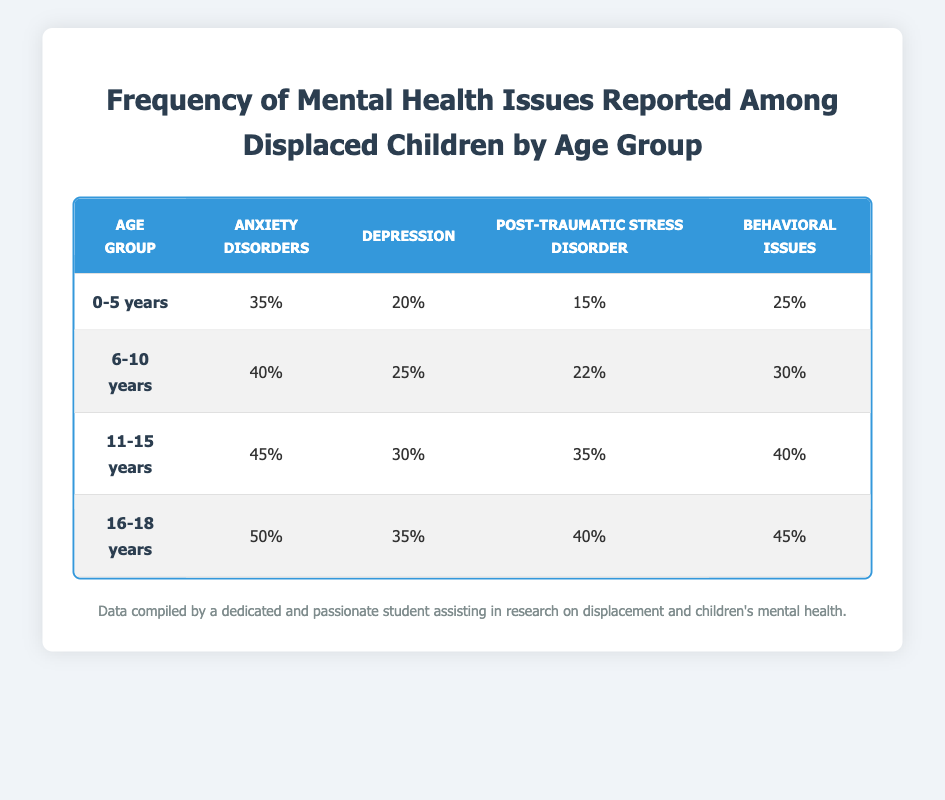What is the percentage of anxiety disorders reported among 11-15 years old? The table shows that for the age group 11-15 years, the percentage of anxiety disorders is provided directly. It states 45% for this age group.
Answer: 45% Which age group has the highest prevalence of depression? By comparing the depression percentages across age groups, we see that the age group 16-18 years has the highest percentage of depression reported at 35%.
Answer: 16-18 years What is the total percentage of behavioral issues across all age groups? To find the total percentage of behavioral issues, we sum the values: 25% (0-5 years) + 30% (6-10 years) + 40% (11-15 years) + 45% (16-18 years) = 140%.
Answer: 140% Is it true that the percentage of post-traumatic stress disorder is equal for age groups 11-15 years and 16-18 years? Checking the table, we find that the percentage of post-traumatic stress disorder is 35% for 11-15 years and 40% for 16-18 years. Since these values are not equal, the answer is false.
Answer: False What is the average percentage of anxiety disorders among children aged 0-10 years? First, we find the percentages for anxiety disorders in age groups 0-5 years (35%) and 6-10 years (40%). The average is then calculated: (35 + 40) / 2 = 37.5%.
Answer: 37.5% Which age group shows the greatest difference in percentage between behavioral issues and anxiety disorders? Looking at the table, we calculate the differences for each age group: 0-5 years: 25% - 35% = -10%; 6-10 years: 30% - 40% = -10%; 11-15 years: 40% - 45% = -5%; 16-18 years: 45% - 50% = -5%. The greatest difference is -10% for both 0-5 years and 6-10 years.
Answer: 0-5 years and 6-10 years What percentage of displaced children aged 16-18 years report anxiety disorders, depression, and post-traumatic stress disorder combined? For the age group 16-18 years, anxiety disorders are 50%, depression is 35%, and post-traumatic stress disorder is 40%. Adding these together gives: 50 + 35 + 40 = 125%.
Answer: 125% Identify the age group that has the lowest percentage of post-traumatic stress disorder. The table shows that for the age group 0-5 years, the percentage of post-traumatic stress disorder is 15%, which is lower than any other group.
Answer: 0-5 years Which mental health issue is reported most frequently among children aged 11-15 years? Referring to the table, the highest percentage of mental health issues for the age group 11-15 years is anxiety disorders at 45%.
Answer: Anxiety disorders 